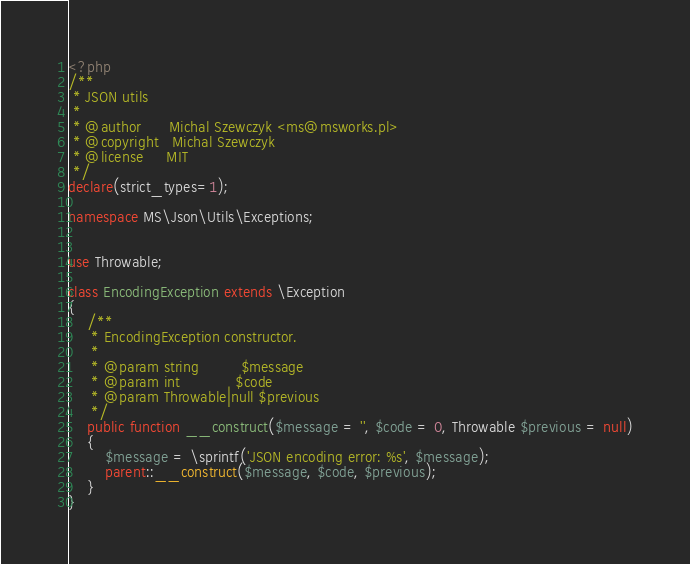Convert code to text. <code><loc_0><loc_0><loc_500><loc_500><_PHP_><?php
/**
 * JSON utils
 *
 * @author      Michal Szewczyk <ms@msworks.pl>
 * @copyright   Michal Szewczyk
 * @license     MIT
 */
declare(strict_types=1);

namespace MS\Json\Utils\Exceptions;


use Throwable;

class EncodingException extends \Exception
{
    /**
     * EncodingException constructor.
     *
     * @param string         $message
     * @param int            $code
     * @param Throwable|null $previous
     */
    public function __construct($message = '', $code = 0, Throwable $previous = null)
    {
        $message = \sprintf('JSON encoding error: %s', $message);
        parent::__construct($message, $code, $previous);
    }
}
</code> 